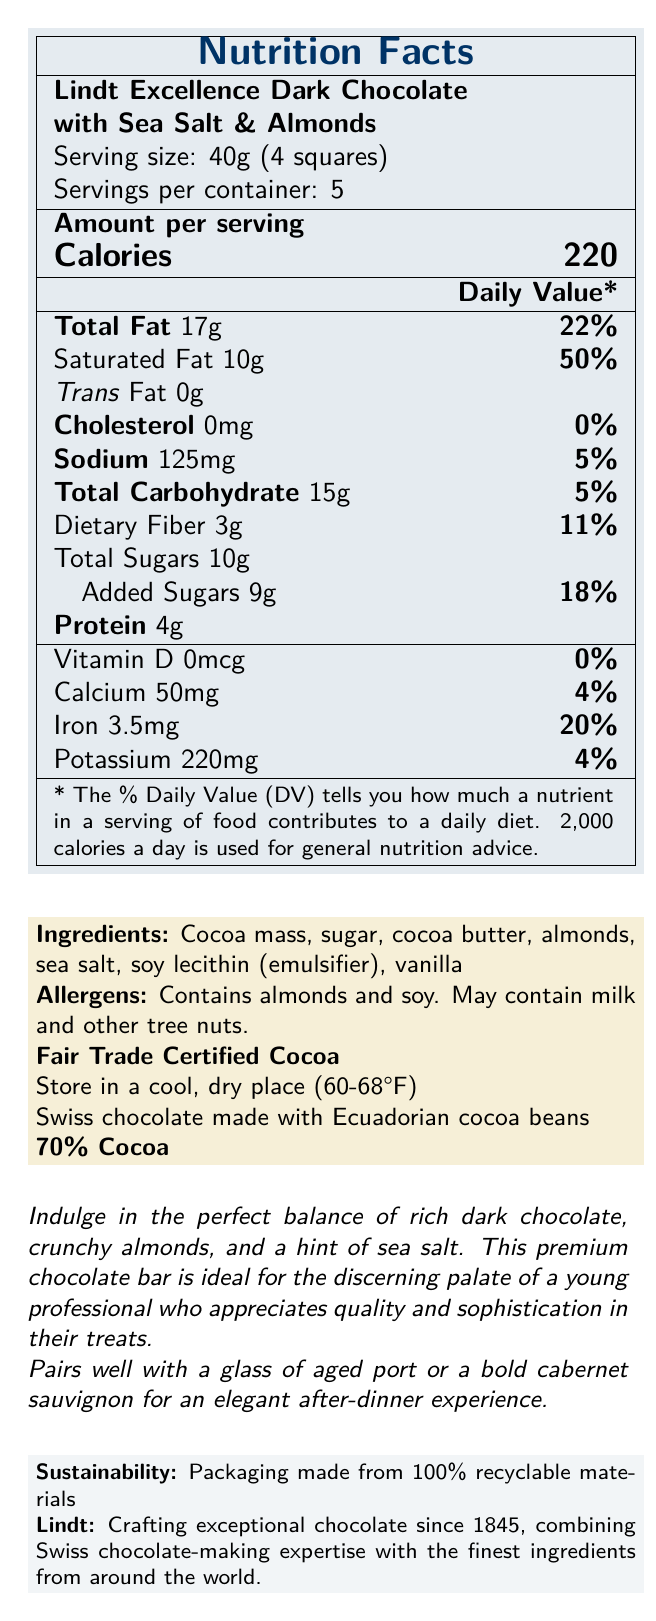what is the serving size of the chocolate bar? The serving size information is clearly mentioned at the top of the nutritional facts section.
Answer: 40g (4 squares) how many calories are there per serving? The Calories per serving is stated under the "Amount per serving" section in large bold text.
Answer: 220 calories how many grams of saturated fat are in one serving? The amount of saturated fat per serving is listed right below "Total Fat" in the nutritional facts section.
Answer: 10g is there any trans fat in this chocolate bar? The nutritional facts state that the trans fat amount is 0g.
Answer: No what are the main ingredients of this chocolate bar? The ingredient list is mentioned in the document below the nutritional information.
Answer: Cocoa mass, sugar, cocoa butter, almonds, sea salt, soy lecithin (emulsifier), vanilla how much protein is there per serving? Protein content per serving is indicated in the nutrition facts section.
Answer: 4g How much sodium is there per serving? A. 100mg B. 125mg C. 150mg D. 175mg The sodium content per serving is specified as 125mg in the nutrition facts.
Answer: B. 125mg what is the daily value percentage of iron provided by this chocolate bar per serving? A. 10% B. 20% C. 30% D. 40% The document lists the daily value percentage of iron next to the iron content, which is 20%.
Answer: B. 20% is there any cholesterol in the chocolate bar? The nutritional facts indicate that the cholesterol content is 0mg.
Answer: No should the chocolate be stored in a humid place? The storage instructions specify storing in a cool, dry place (60-68°F).
Answer: No What is the main idea of this document? The document outlines various details like nutrition facts, ingredients, storage instructions, pairing suggestions, and sustainability attributes for the premium chocolate bar.
Answer: The document provides detailed nutritional information and characteristics of the Lindt Excellence Dark Chocolate with Sea Salt & Almonds, including ingredients, storage instructions, pairing suggestions, and sustainability aspects. where are the cocoa beans sourced from? The origin of the cocoa beans used in the chocolate is mentioned as Ecuadorian in the document.
Answer: Ecuador what is the percentage of cocoa in this chocolate bar? The content of cocoa in the chocolate bar is indicated as 70% in the detailed information.
Answer: 70% does the chocolate bar contain any milk? The allergen information states that it may contain milk and other tree nuts.
Answer: Possibly Does this chocolate pair well with a bold cabernet sauvignon? Pairing suggestions mention that this chocolate pairs well with a glass of aged port or a bold cabernet sauvignon.
Answer: Yes What is the total amount of Calories in the entire container? Since the chocolate bar has 5 servings per container and each serving is 220 calories, multiplying 220 by 5 gives 1100 calories in total.
Answer: 1100 calories Who makes this chocolate? The brand name Lindt is mentioned repeatedly, indicating that Lindt is the manufacturer.
Answer: Lindt is the packaging made from recyclable materials? The sustainability section notes that the packaging is made from 100% recyclable materials.
Answer: Yes What date was Lindt founded? The document provides an overview and history of Lindt but does not specify the founding date.
Answer: Not enough information 